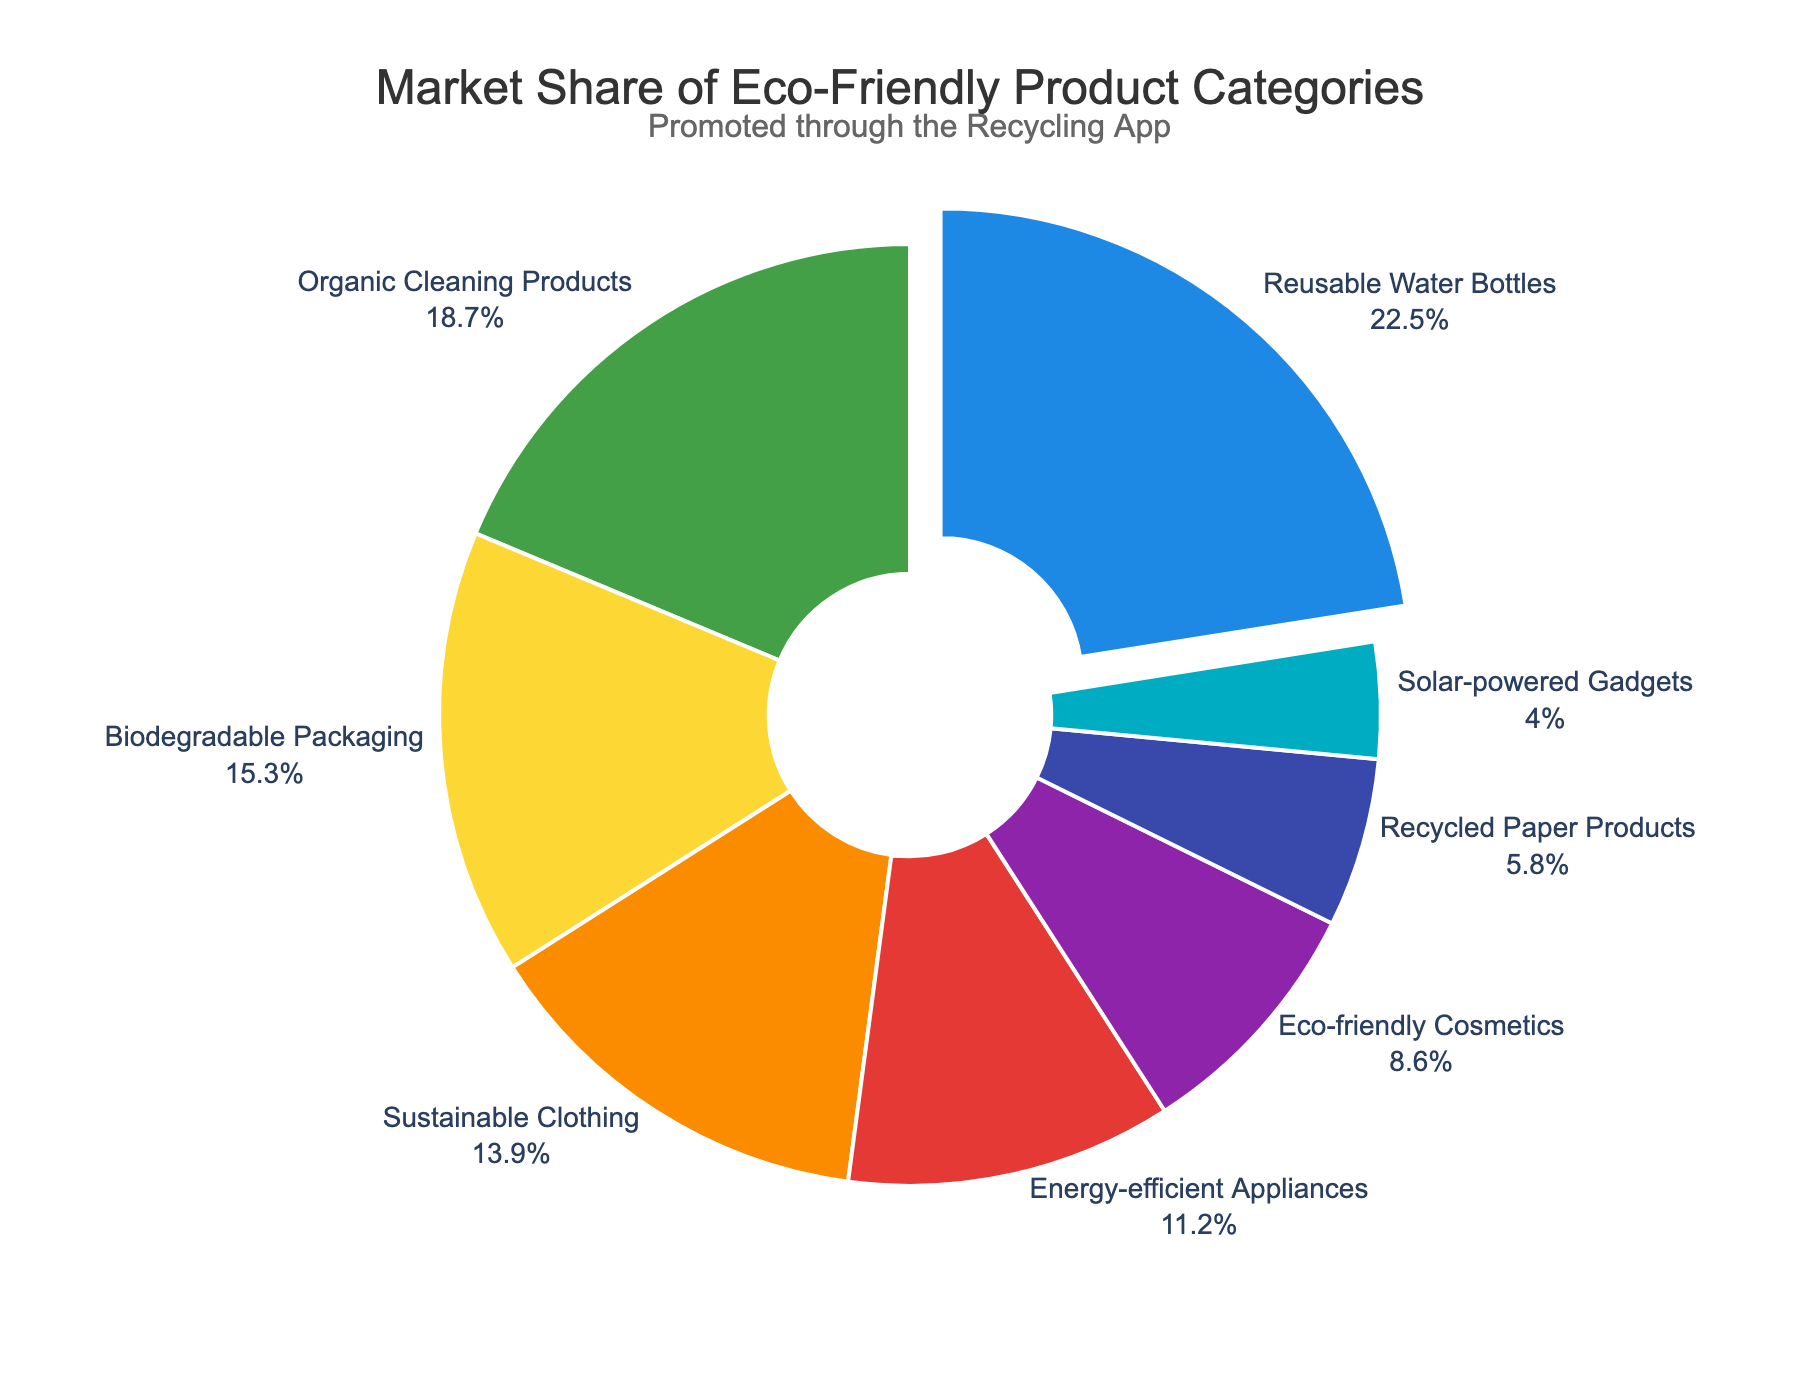What is the market share of Reusable Water Bottles? The figure shows that Reusable Water Bottles have a market share of 22.5%.
Answer: 22.5% Which category has the least market share? By looking at the figure, Solar-powered Gadgets have the smallest slice, indicating it has the least market share of 4.0%.
Answer: Solar-powered Gadgets What is the combined market share of Organic Cleaning Products and Biodegradable Packaging? Organic Cleaning Products have a market share of 18.7% and Biodegradable Packaging has 15.3%. Adding these together, 18.7% + 15.3% = 34.0%.
Answer: 34.0% How does the market share of Sustainable Clothing compare to Energy-efficient Appliances? Sustainable Clothing has a market share of 13.9%, while Energy-efficient Appliances have 11.2%. Therefore, Sustainable Clothing has a greater market share.
Answer: Sustainable Clothing has a greater market share Which product category is represented by the green color in the pie chart? The green color in the pie chart represents Organic Cleaning Products.
Answer: Organic Cleaning Products What proportion of the market does Recycled Paper Products and Solar-powered Gadgets together hold? Recycled Paper Products have a market share of 5.8% and Solar-powered Gadgets have 4.0%. Adding these together, 5.8% + 4.0% = 9.8%.
Answer: 9.8% By how much does the market share of Reusable Water Bottles exceed that of Eco-friendly Cosmetics? Reusable Water Bottles have a market share of 22.5%, and Eco-friendly Cosmetics have 8.6%. The difference is 22.5% - 8.6% = 13.9%.
Answer: 13.9% What is the market share of the top three product categories combined? The top three product categories are Reusable Water Bottles (22.5%), Organic Cleaning Products (18.7%), and Biodegradable Packaging (15.3%). Adding these together, 22.5% + 18.7% + 15.3% = 56.5%.
Answer: 56.5% Are there any product categories with an equal market share? By inspecting the pie chart, no two categories have identical slices or represented values, so there are no categories with equal market shares.
Answer: No What's the market share difference between the highest and lowest categories? The highest market share is Reusable Water Bottles at 22.5%, and the lowest is Solar-powered Gadgets at 4.0%. The difference is 22.5% - 4.0% = 18.5%.
Answer: 18.5% 